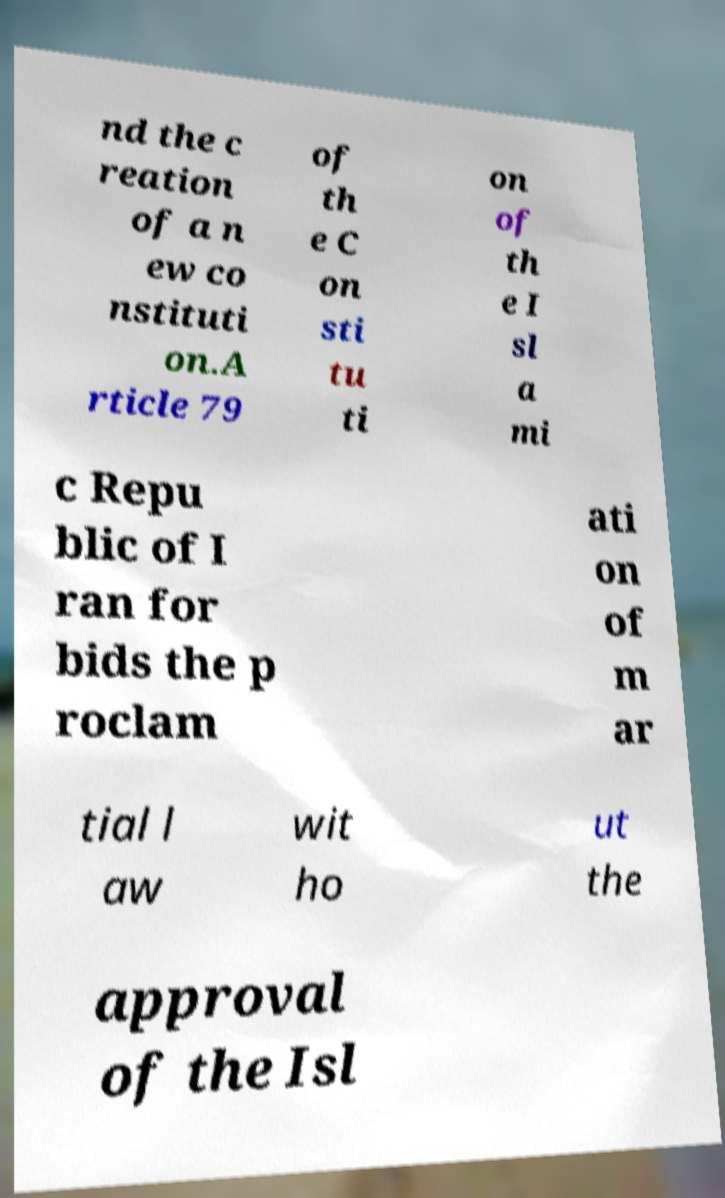Can you accurately transcribe the text from the provided image for me? nd the c reation of a n ew co nstituti on.A rticle 79 of th e C on sti tu ti on of th e I sl a mi c Repu blic of I ran for bids the p roclam ati on of m ar tial l aw wit ho ut the approval of the Isl 